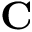<formula> <loc_0><loc_0><loc_500><loc_500>C</formula> 